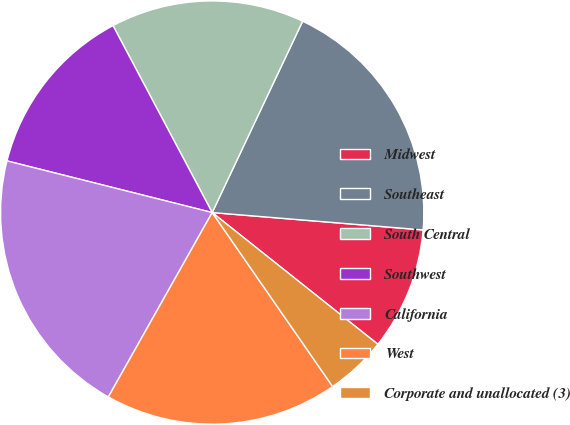Convert chart to OTSL. <chart><loc_0><loc_0><loc_500><loc_500><pie_chart><fcel>Midwest<fcel>Southeast<fcel>South Central<fcel>Southwest<fcel>California<fcel>West<fcel>Corporate and unallocated (3)<nl><fcel>9.38%<fcel>19.28%<fcel>14.79%<fcel>13.31%<fcel>20.76%<fcel>17.8%<fcel>4.67%<nl></chart> 